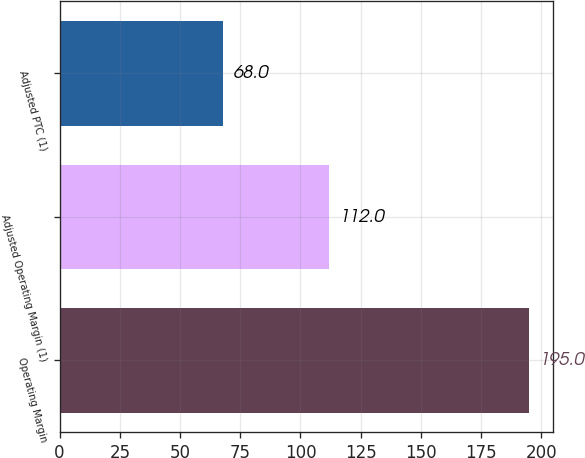Convert chart. <chart><loc_0><loc_0><loc_500><loc_500><bar_chart><fcel>Operating Margin<fcel>Adjusted Operating Margin (1)<fcel>Adjusted PTC (1)<nl><fcel>195<fcel>112<fcel>68<nl></chart> 